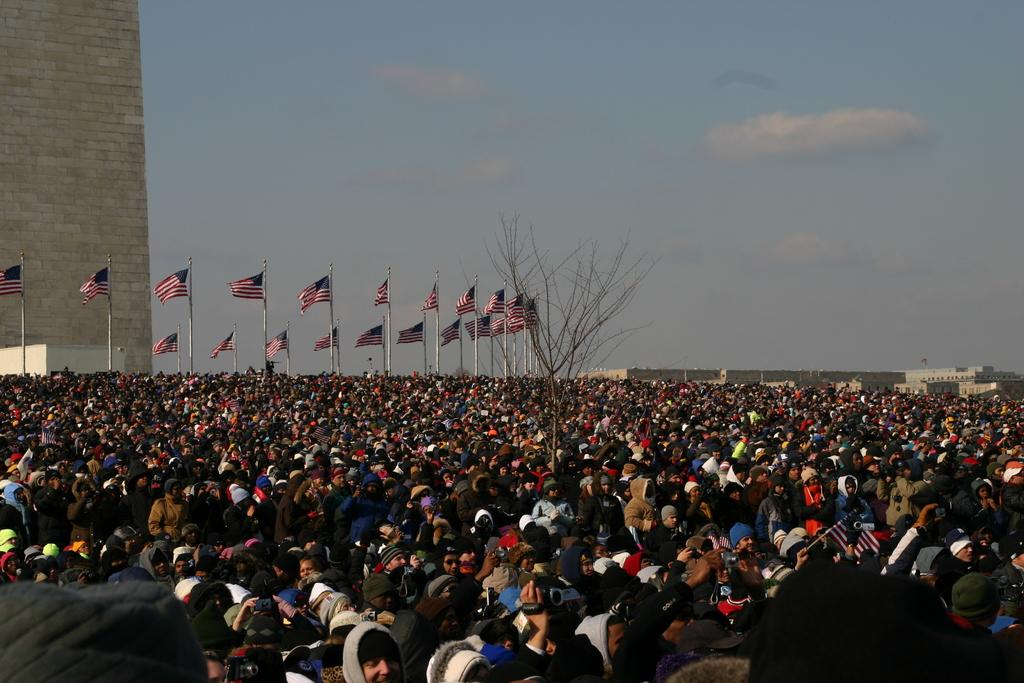How many people are in the group shown in the image? The number of people in the group cannot be determined from the provided facts. What are the people holding in the image? Some people are holding something, but the specific objects cannot be identified from the facts. What can be seen in the background of the image? There are flags and buildings visible in the background. What is the color of the sky in the image? The sky is a combination of white and blue colors. What type of mark can be seen on the train in the image? There is no train present in the image, so it is not possible to determine if there is a mark on it. 